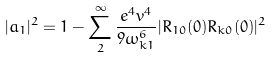Convert formula to latex. <formula><loc_0><loc_0><loc_500><loc_500>| a _ { 1 } | ^ { 2 } = 1 - \sum _ { 2 } ^ { \infty } \frac { e ^ { 4 } v ^ { 4 } } { 9 \omega _ { k 1 } ^ { 6 } } | R _ { 1 0 } ( 0 ) R _ { k 0 } ( 0 ) | ^ { 2 }</formula> 